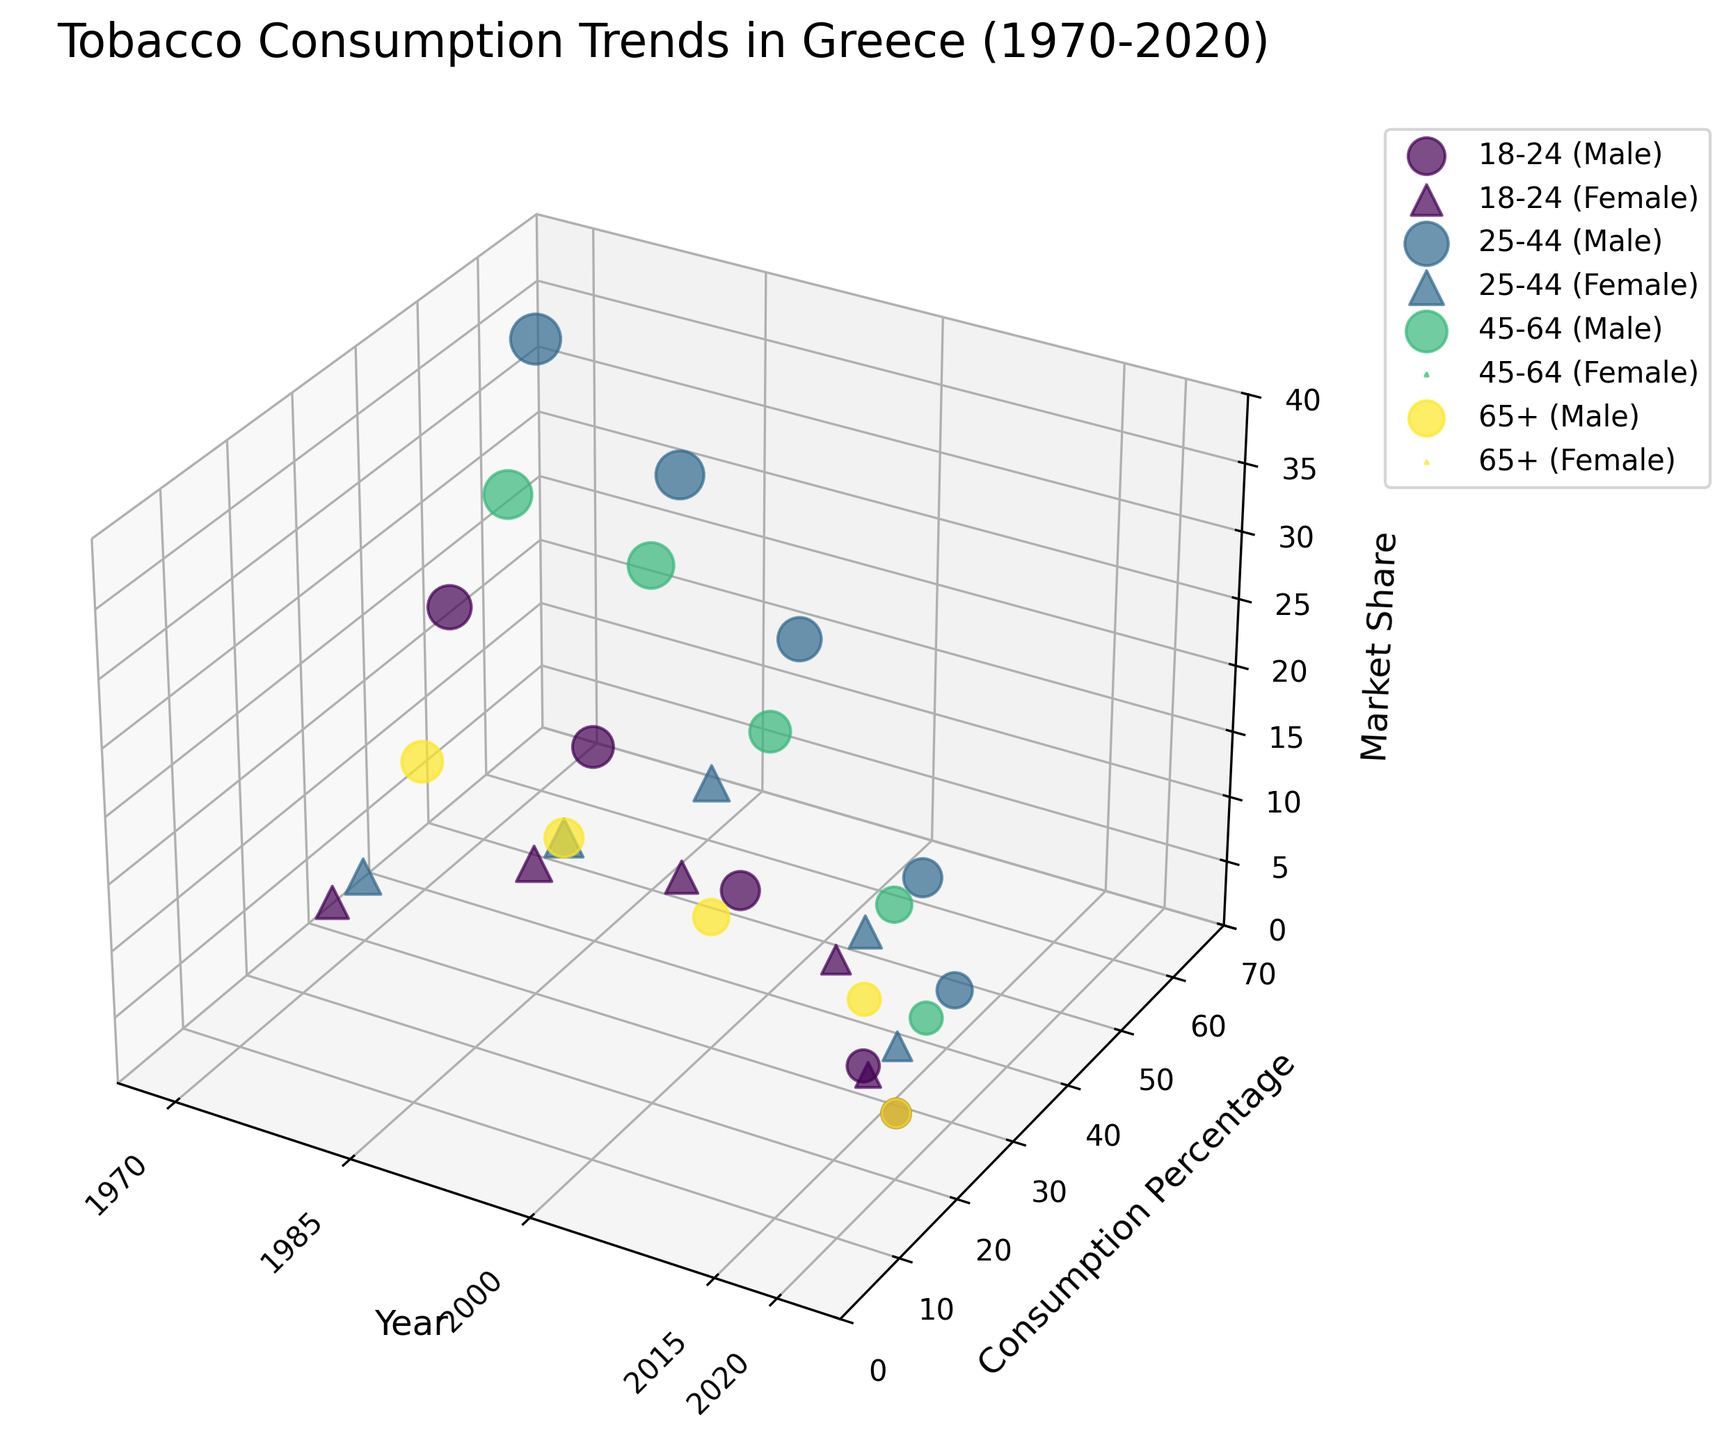What's the title of the figure? The title is located at the top of the figure. It reads "Tobacco Consumption Trends in Greece (1970-2020)"
Answer: Tobacco Consumption Trends in Greece (1970-2020) Which age group has the highest consumption percentage in 1970? Checking the data points for 1970, the 25-44 Male group has the highest consumption percentage at 60%.
Answer: 25-44 Male How many unique age groups are there in the figure? By examining the different age groups shown in the legend and data points, we find four unique age groups: 18-24, 25-44, 45-64, and 65+.
Answer: 4 What is the market share of 25-44 Female in 1985? The market share for the 25-44 Female group in 1985 can be read directly from the data: it is 10%.
Answer: 10% Compare the consumption percentage of 18-24 Males between 1970 and 2020. How much has it changed? In 1970, the consumption percentage for 18-24 Males was 45%. In 2020, it is 20%. The change is 45% - 20% = 25%.
Answer: 25% Which gender has more markers in the chart? Both genders have equal markers because the data includes both Males and Females for each age group and time point.
Answer: Equal What is the trend in consumption percentage for 45-64 Males from 1970 to 2020? Observing the data points for 45-64 Males: 1970: 55%, 1985: 50%, 2000: 40%, 2015: 30%, 2020: 25%. The trend shows a consistent decline in consumption percentage over the years.
Answer: Decline Which age-gender group had the largest market share in 2000? The 25-44 Female group had a market share of 20% in 2000, the highest among all groups for that year.
Answer: 25-44 Female Compare the consumption trends of 18-24 Males and Females between 1970 and 2020. In 1970, the consumption percentage for 18-24 Males is 45%, while for Females, it is 25%. In 2020, the consumption percentage for 18-24 Males is 20%, and for Females, it is 15%. Both have decreased, but Males have a larger overall decrease of 25% compared to 10% for Females.
Answer: Males decreased by 25%, Females by 10% Which age group, regardless of gender, had the highest consumption percentage in 2000? The data shows that, regardless of gender, the 25-44 age group had the highest consumption percentage at 45% for Males and 30% for Females in the year 2000.
Answer: 25-44 